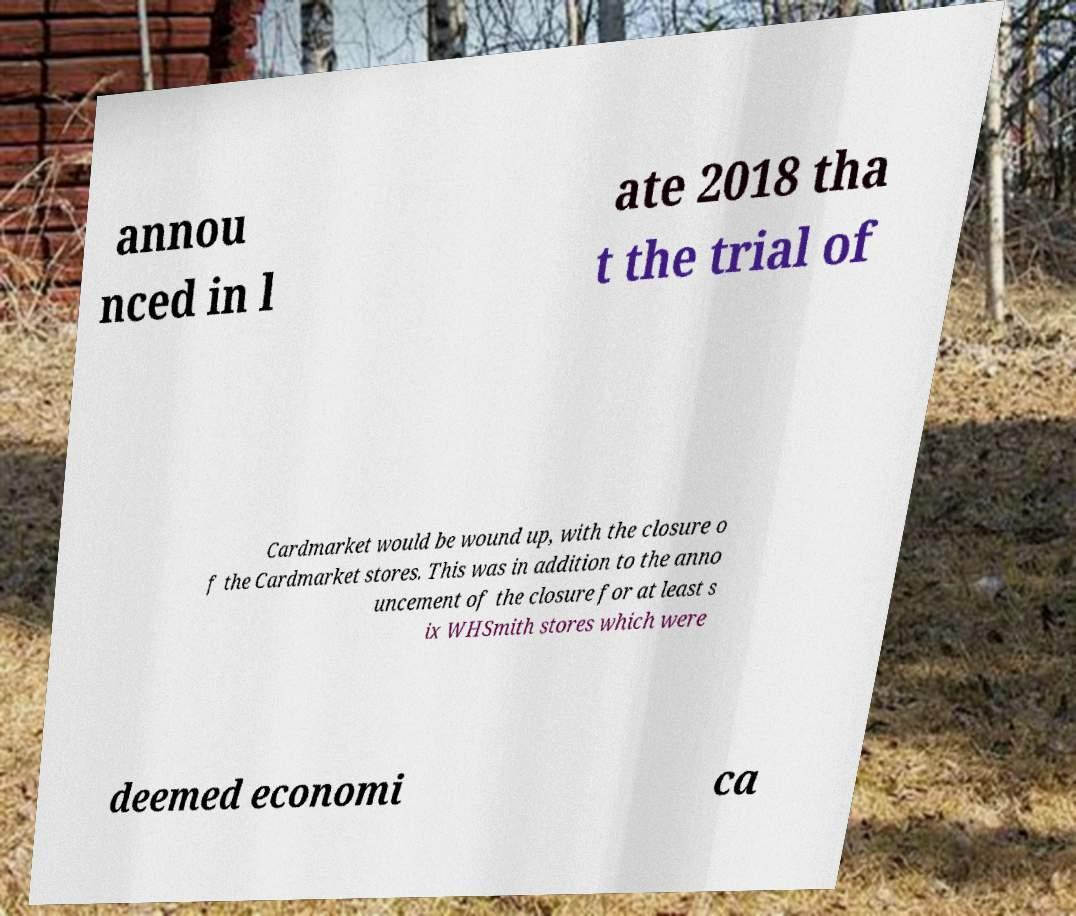Could you extract and type out the text from this image? annou nced in l ate 2018 tha t the trial of Cardmarket would be wound up, with the closure o f the Cardmarket stores. This was in addition to the anno uncement of the closure for at least s ix WHSmith stores which were deemed economi ca 